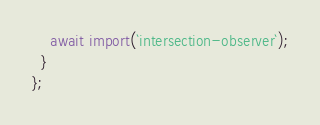<code> <loc_0><loc_0><loc_500><loc_500><_JavaScript_>    await import(`intersection-observer`);
  }
};
</code> 